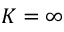Convert formula to latex. <formula><loc_0><loc_0><loc_500><loc_500>K = \infty</formula> 